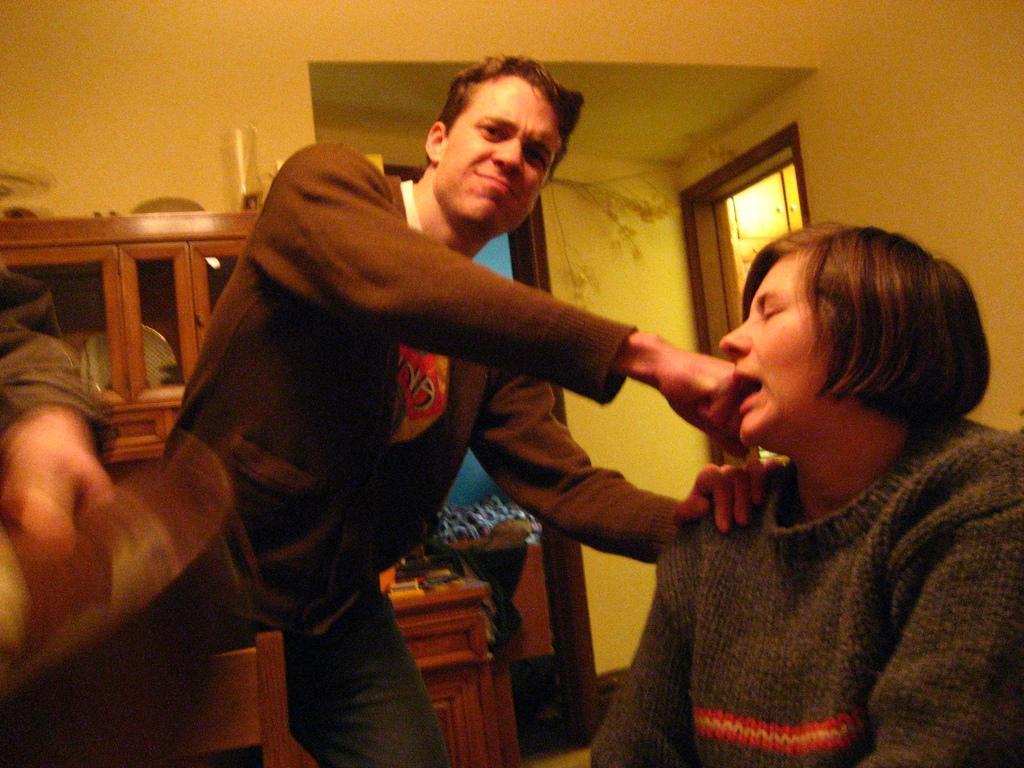Can you describe this image briefly? In this image there are persons sitting and standing. In the background there is a cup board, there are doors and on the top of the cupboard there is glass. 